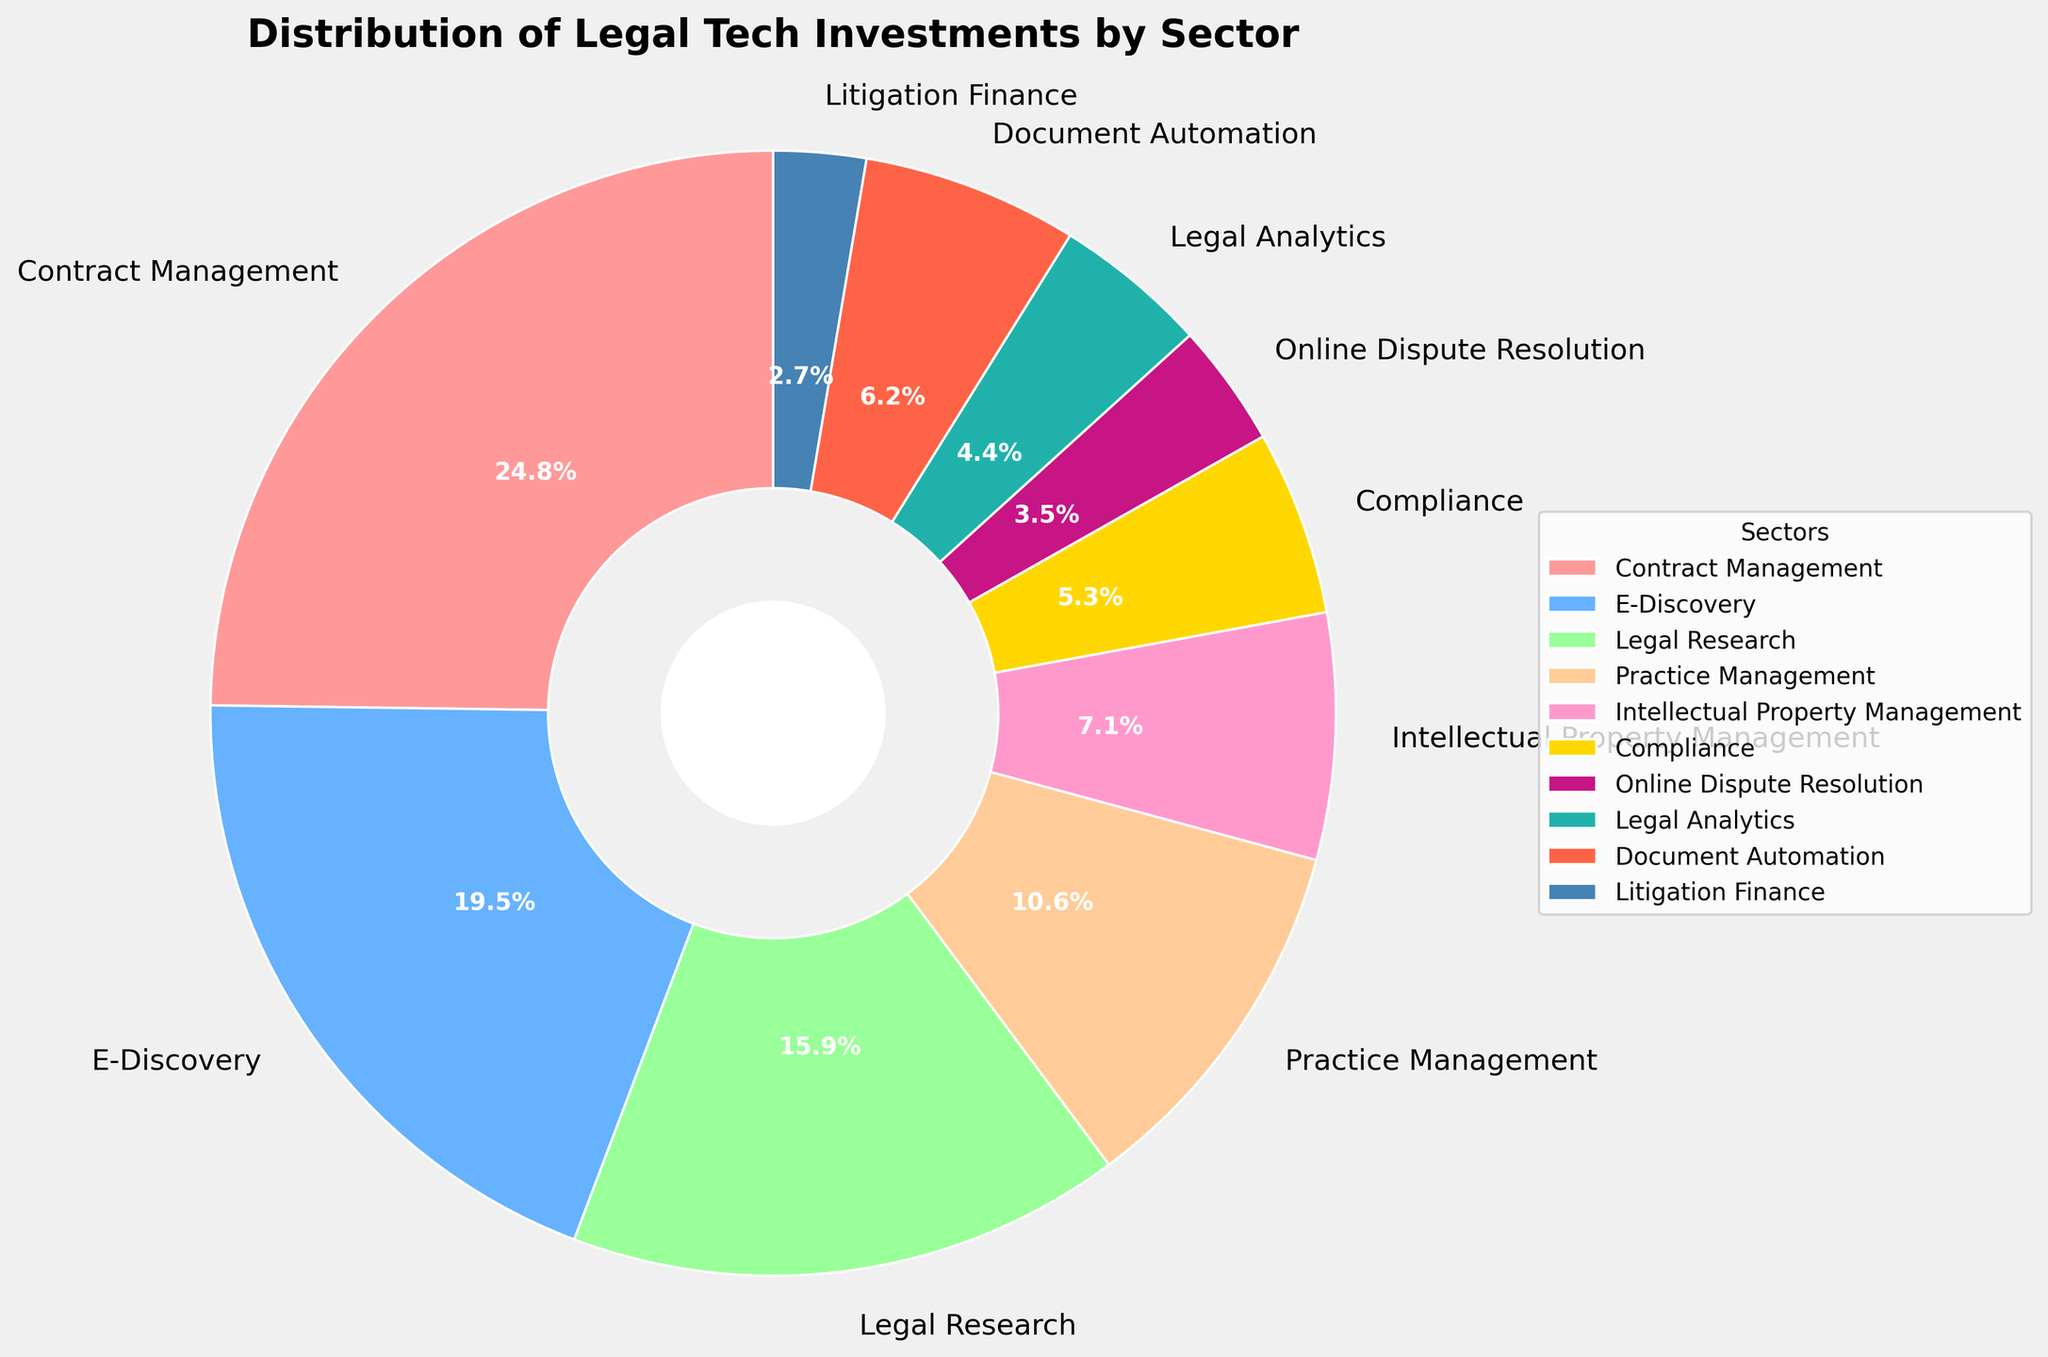Which sector has the highest percentage of legal tech investment? Look for the sector with the largest slice in the pie chart. Contract Management takes up the largest portion.
Answer: Contract Management What is the combined percentage of investments in E-Discovery and Legal Research sectors? Identify the percentages for E-Discovery (22%) and Legal Research (18%), then add them up: 22% + 18% = 40%.
Answer: 40% How much less is the investment in Compliance compared to Contract Management? Find the percentage for Compliance (6%) and Contract Management (28%), then subtract Compliance's value from Contract Management's: 28% - 6% = 22%.
Answer: 22% Which sector receives the least investment, and what is its percentage? Look for the smallest slice in the pie chart, which represents Litigation Finance with 3%.
Answer: Litigation Finance, 3% Is Practice Management investment higher or lower than E-Discovery? Compare the two percentages: Practice Management is 12% while E-Discovery is 22%. Practice Management is lower.
Answer: Lower What are the three sectors with the smallest investment percentages, and what are their combined share? Identify the three smallest sectors (Litigation Finance, Online Dispute Resolution, and Legal Analytics) and sum their percentages: 3% (Litigation Finance) + 4% (Online Dispute Resolution) + 5% (Legal Analytics) = 12%.
Answer: Litigation Finance, Online Dispute Resolution, Legal Analytics; 12% How much more investment does Document Automation get compared to Online Dispute Resolution? Find the percentages for Document Automation (7%) and Online Dispute Resolution (4%), then subtract the smaller from the larger: 7% - 4% = 3%.
Answer: 3% What is the percentage difference between Intellectual Property Management and Compliance? Calculate the percentages of Intellectual Property Management (8%) and Compliance (6%), then subtract Compliance from Intellectual Property Management: 8% - 6% = 2%.
Answer: 2% Which sectors have investment percentages greater than 10%? Identify the sectors with figures higher than 10%: Contract Management (28%), E-Discovery (22%), and Legal Research (18%).
Answer: Contract Management, E-Discovery, Legal Research If the total investment was $100 million, how much investment in dollars did the Legal Research sector receive? Calculate the dollar value by multiplying the total investment by the percentage in decimal form: $100 million * 0.18 = $18 million.
Answer: $18 million 